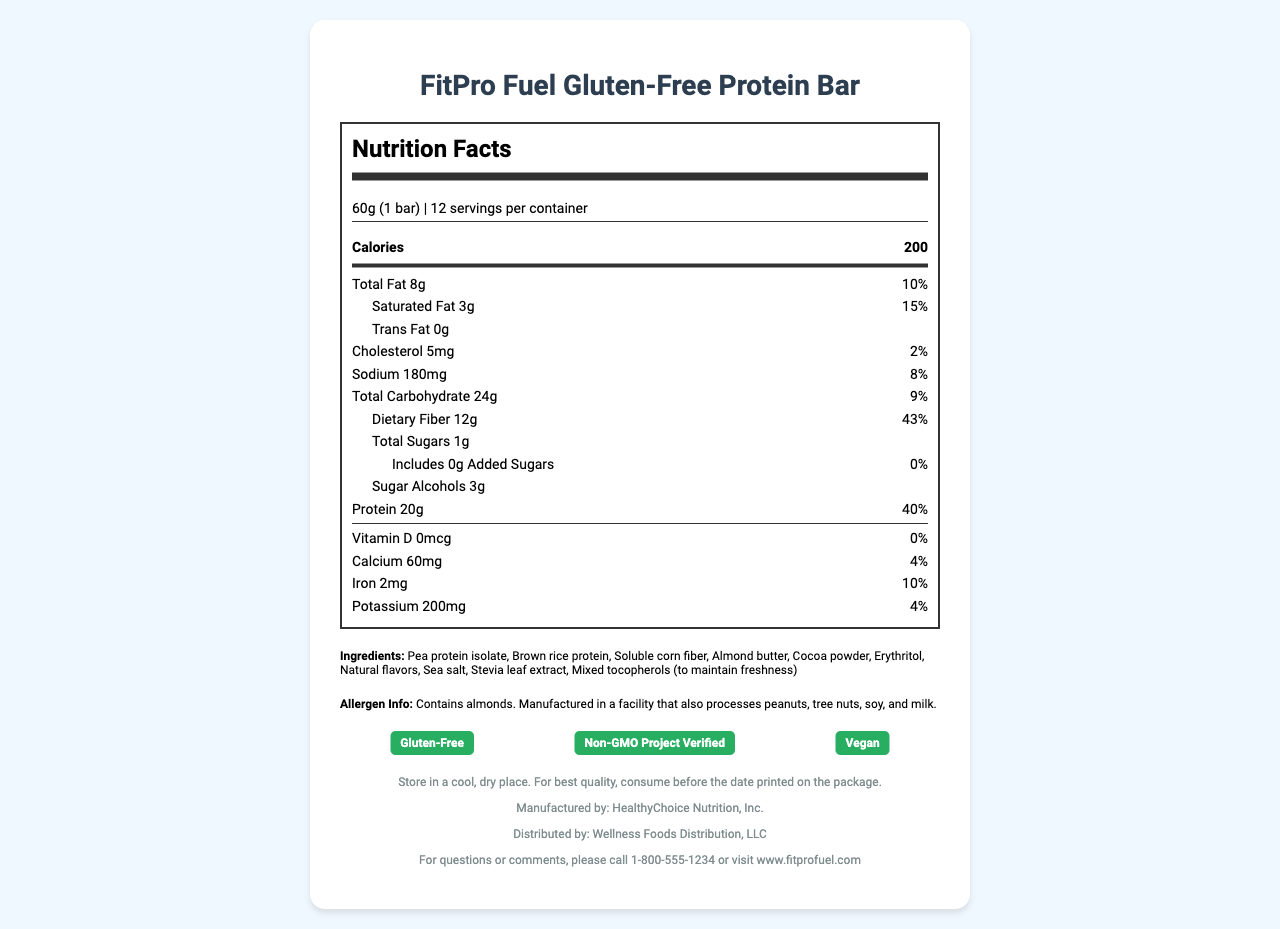what is the serving size? The serving size is clearly mentioned at the top of the Nutrition Facts label: "60g (1 bar)".
Answer: 60g (1 bar) how many calories are in one serving of the protein bar? The calorie content is displayed just below the serving size on the Nutrition Facts label: "Calories 200".
Answer: 200 how much protein is in one serving of the FitPro Fuel Gluten-Free Protein Bar? The amount of protein per serving is listed towards the bottom of the Nutrition Facts label: "Protein 20g".
Answer: 20g how much dietary fiber is in each serving? The dietary fiber content is found under the Total Carbohydrate section: "Dietary Fiber 12g".
Answer: 12g what percentage of the daily value does the protein content represent? The daily value percentage for protein is listed next to the protein content: "20g 40%".
Answer: 40% what is the main ingredient in the FitPro Fuel Gluten-Free Protein Bar? A. Almond butter B. Pea protein isolate C. Cocoa powder D. Brown rice protein The ingredients are listed in descending order of their predominance: "Pea protein isolate, Brown rice protein, Soluble corn fiber...".
Answer: B what certifications does the FitPro Fuel Gluten-Free Protein Bar have? A. Gluten-Free B. Non-GMO Project Verified C. Vegan D. All of the above The certifications listed at the bottom of the document include all the choices: "Gluten-Free", "Non-GMO Project Verified", "Vegan".
Answer: D does this product contain any added sugars? The Nutrition Facts label specifies "Includes 0g Added Sugars".
Answer: No what nutrient has the highest daily value percentage? The daily value percentage for dietary fiber is 43%, which is the highest among the listed nutrients.
Answer: Dietary Fiber which company manufactures the FitPro Fuel Gluten-Free Protein Bar? The manufacturer is listed at the bottom of the document: "Manufactured by: HealthyChoice Nutrition, Inc.".
Answer: HealthyChoice Nutrition, Inc. summarize the main nutritional benefits of the FitPro Fuel Gluten-Free Protein Bar. This summary captures the main nutritional benefits as they pertain to protein and fiber content, as well as the product's compliance with dietary constraints, based on the provided nutrition facts and certifications.
Answer: The FitPro Fuel Gluten-Free Protein Bar is designed to be a nutritious snack with a high protein content of 20g, a significant amount of dietary fiber at 12g, and only 1g of total sugars per serving. It is also certified gluten-free, non-GMO, and vegan, making it a suitable choice for individuals with specific dietary preferences or restrictions. what is the maximum acceptable storage temperature for this product? The document only advises to store in a cool, dry place, but it does not specify a maximum acceptable storage temperature.
Answer: Not enough information 